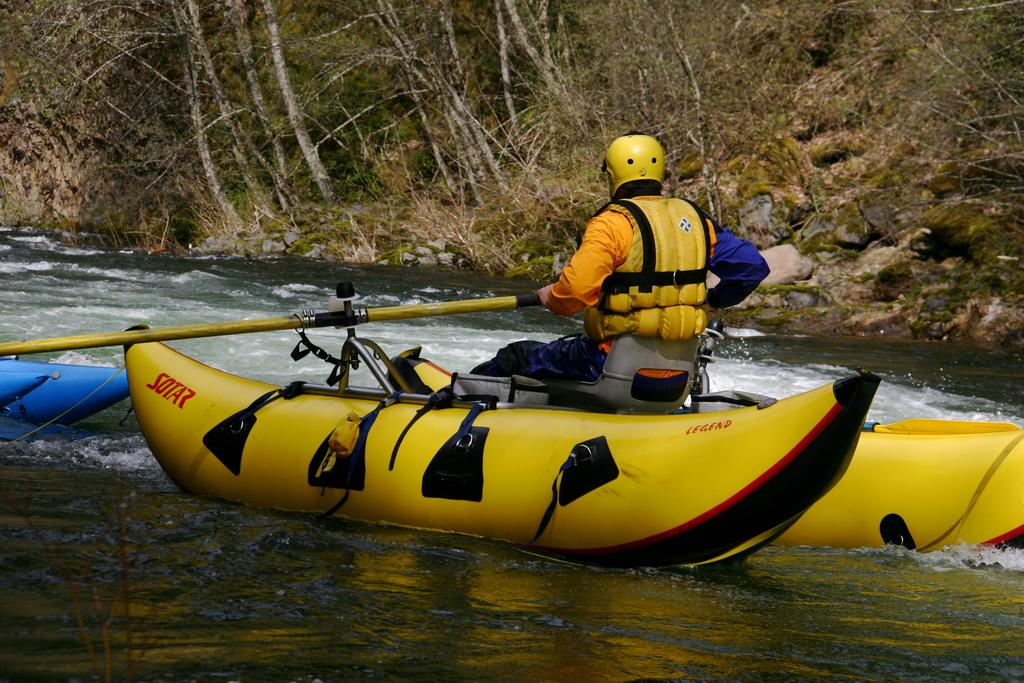<image>
Describe the image concisely. A man in a Sotar river raft is wearing a yellow helmet. 